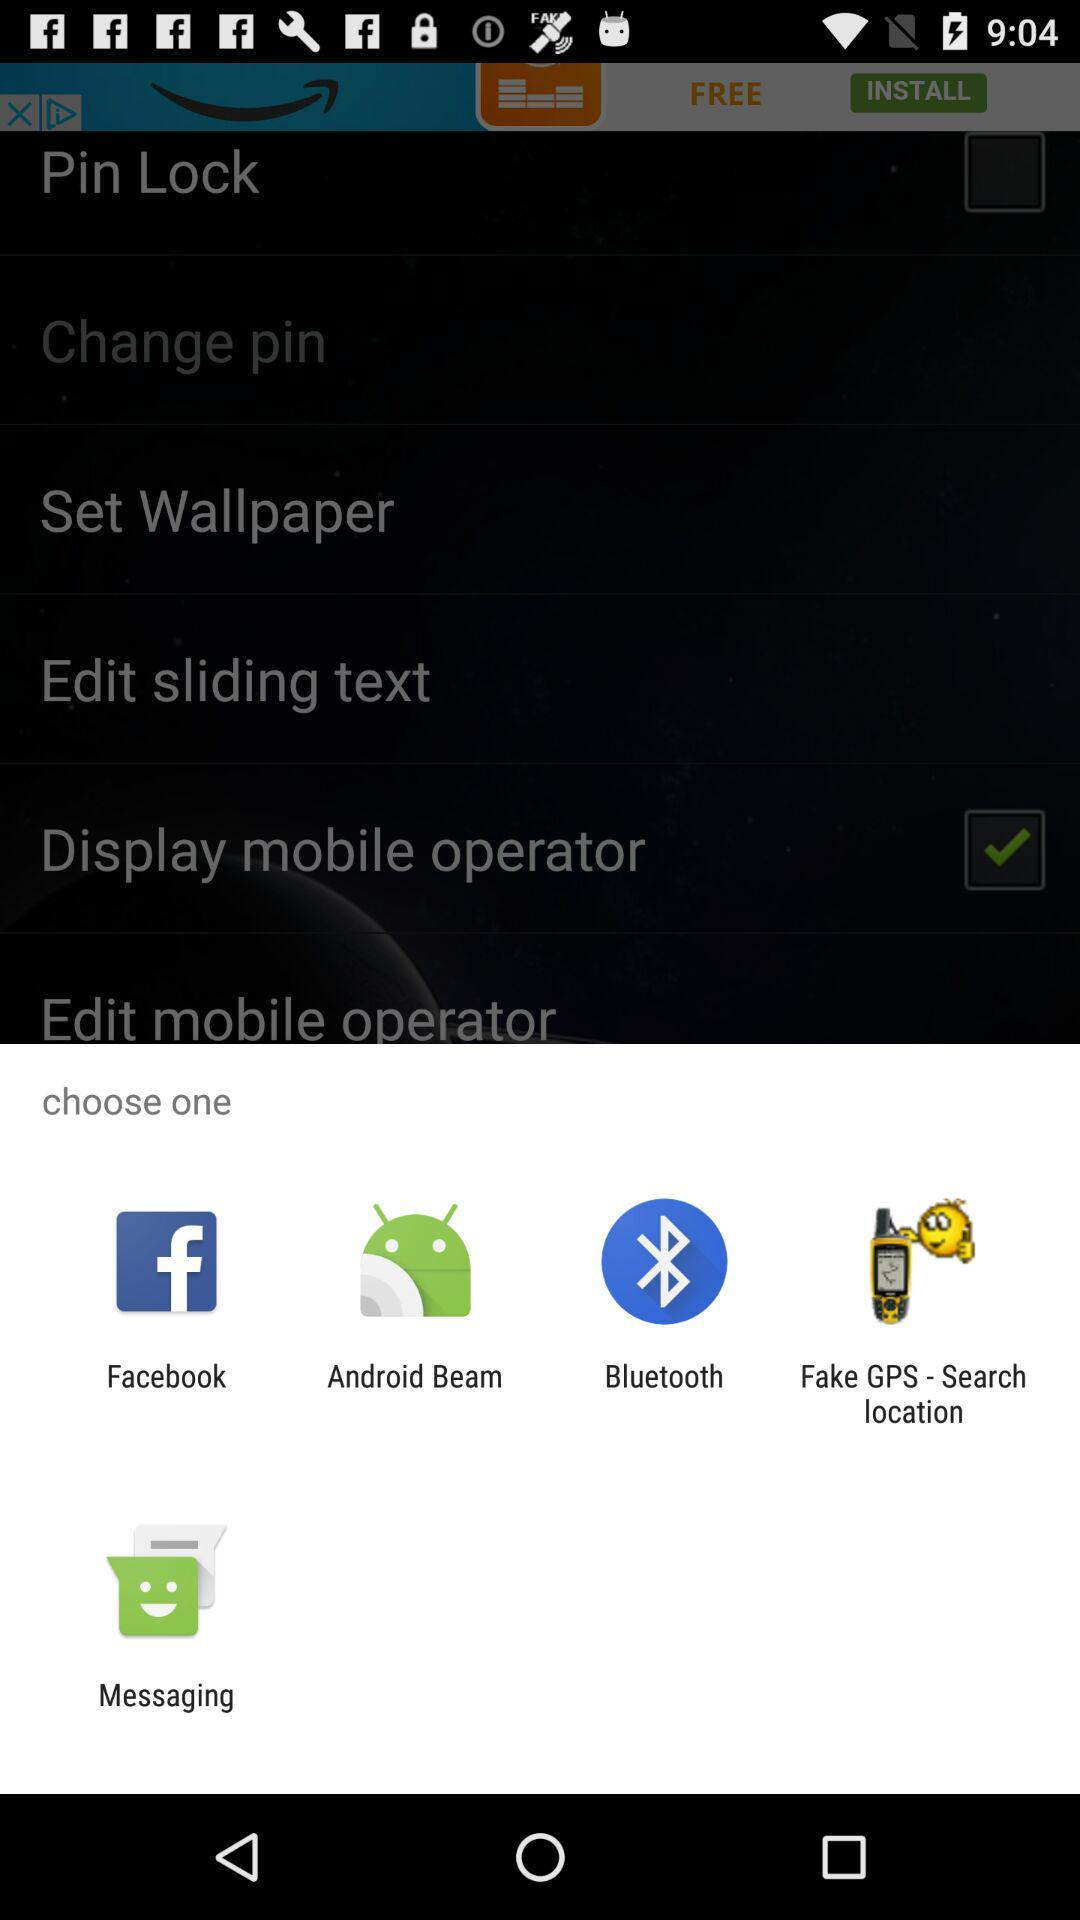How many characters are in the pin?
When the provided information is insufficient, respond with <no answer>. <no answer> 